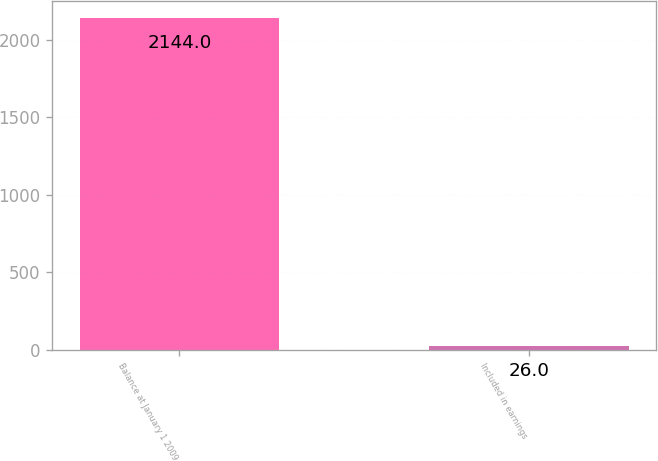Convert chart. <chart><loc_0><loc_0><loc_500><loc_500><bar_chart><fcel>Balance at January 1 2009<fcel>Included in earnings<nl><fcel>2144<fcel>26<nl></chart> 